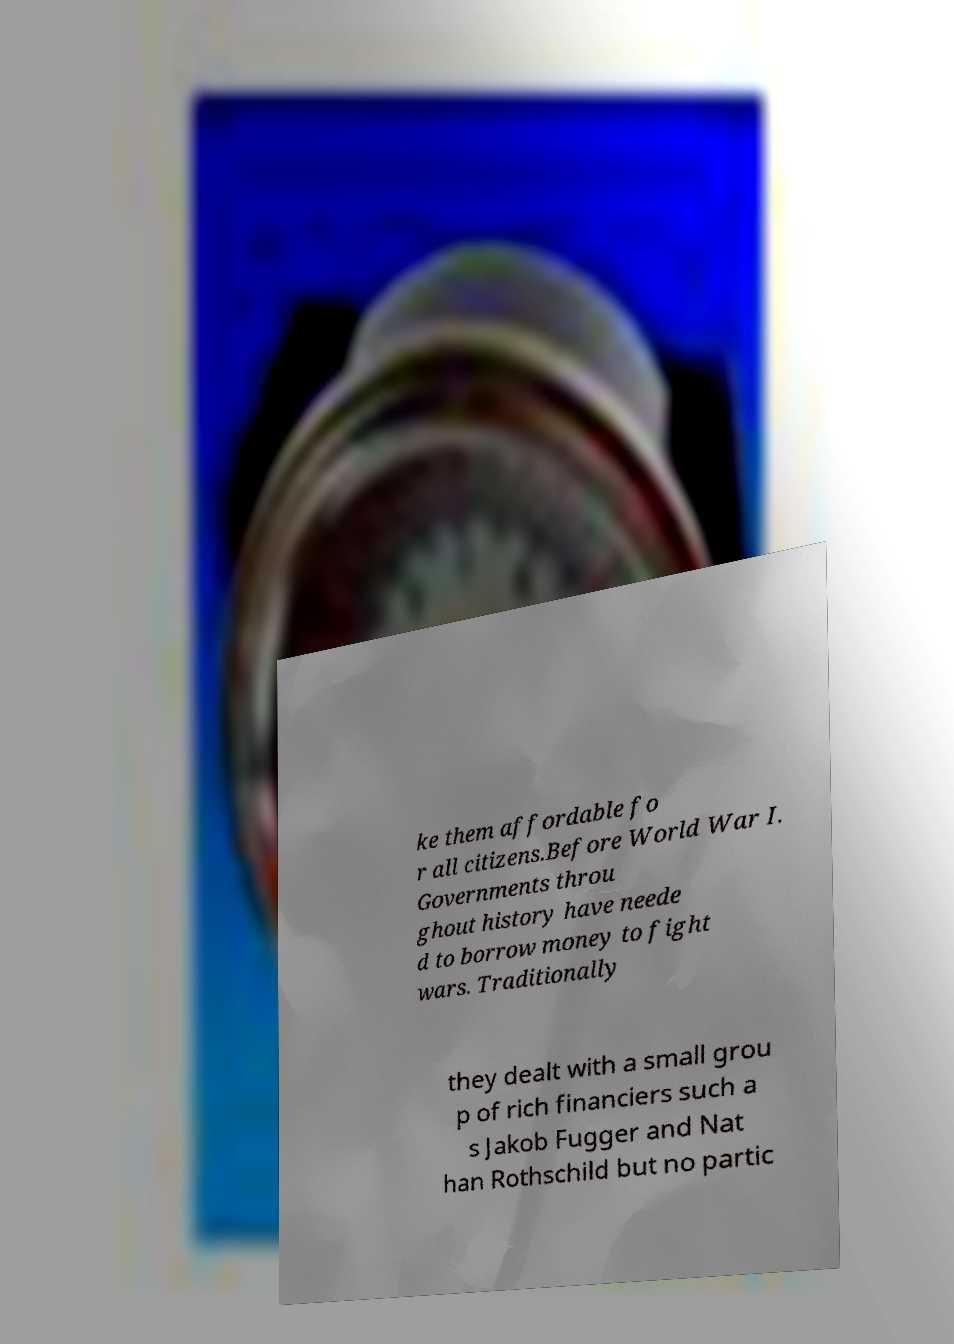What messages or text are displayed in this image? I need them in a readable, typed format. ke them affordable fo r all citizens.Before World War I. Governments throu ghout history have neede d to borrow money to fight wars. Traditionally they dealt with a small grou p of rich financiers such a s Jakob Fugger and Nat han Rothschild but no partic 